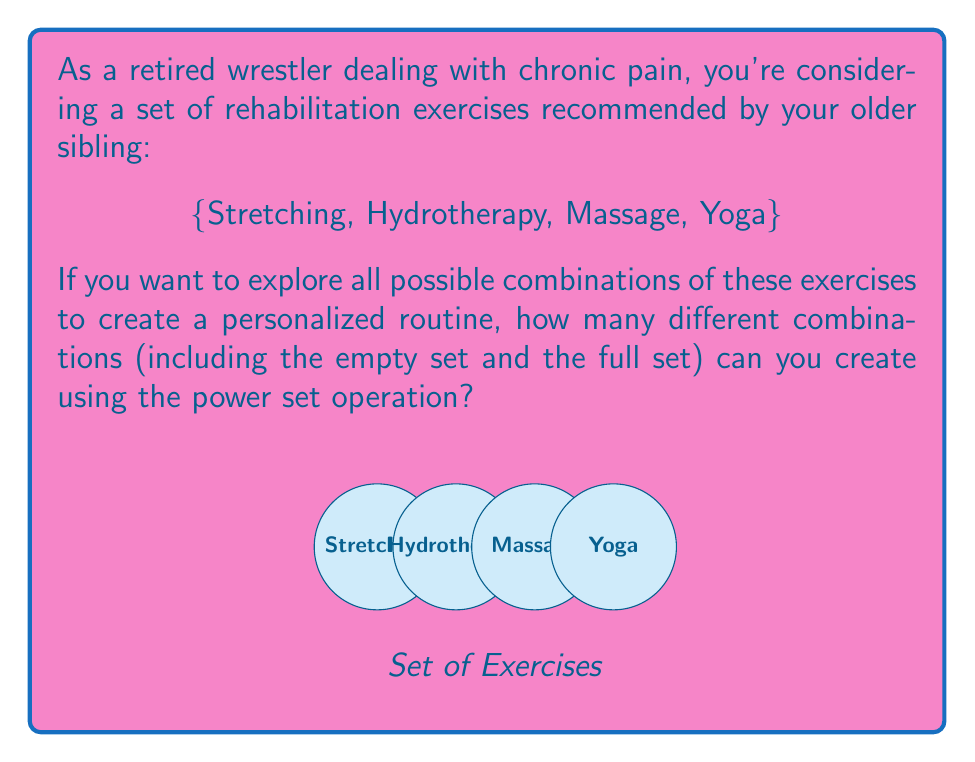Give your solution to this math problem. Let's approach this step-by-step:

1) First, recall that the power set of a set $S$ is the set of all subsets of $S$, including the empty set and $S$ itself. We denote this as $P(S)$.

2) In this case, our set $S$ = {Stretching, Hydrotherapy, Massage, Yoga}

3) To find the number of elements in the power set, we can use the formula:
   
   $$ |P(S)| = 2^n $$
   
   where $n$ is the number of elements in the original set $S$.

4) We have 4 elements in our original set, so $n = 4$.

5) Plugging this into our formula:

   $$ |P(S)| = 2^4 = 16 $$

6) To verify, we can list out all possible combinations:
   - Empty set: {}
   - Single element sets: {S}, {H}, {M}, {Y}
   - Two element sets: {S,H}, {S,M}, {S,Y}, {H,M}, {H,Y}, {M,Y}
   - Three element sets: {S,H,M}, {S,H,Y}, {S,M,Y}, {H,M,Y}
   - Full set: {S,H,M,Y}

   Indeed, we have 16 total combinations.

This means you can create 16 different exercise routines, ranging from doing no exercises (empty set) to doing all exercises (full set), with various combinations in between.
Answer: 16 